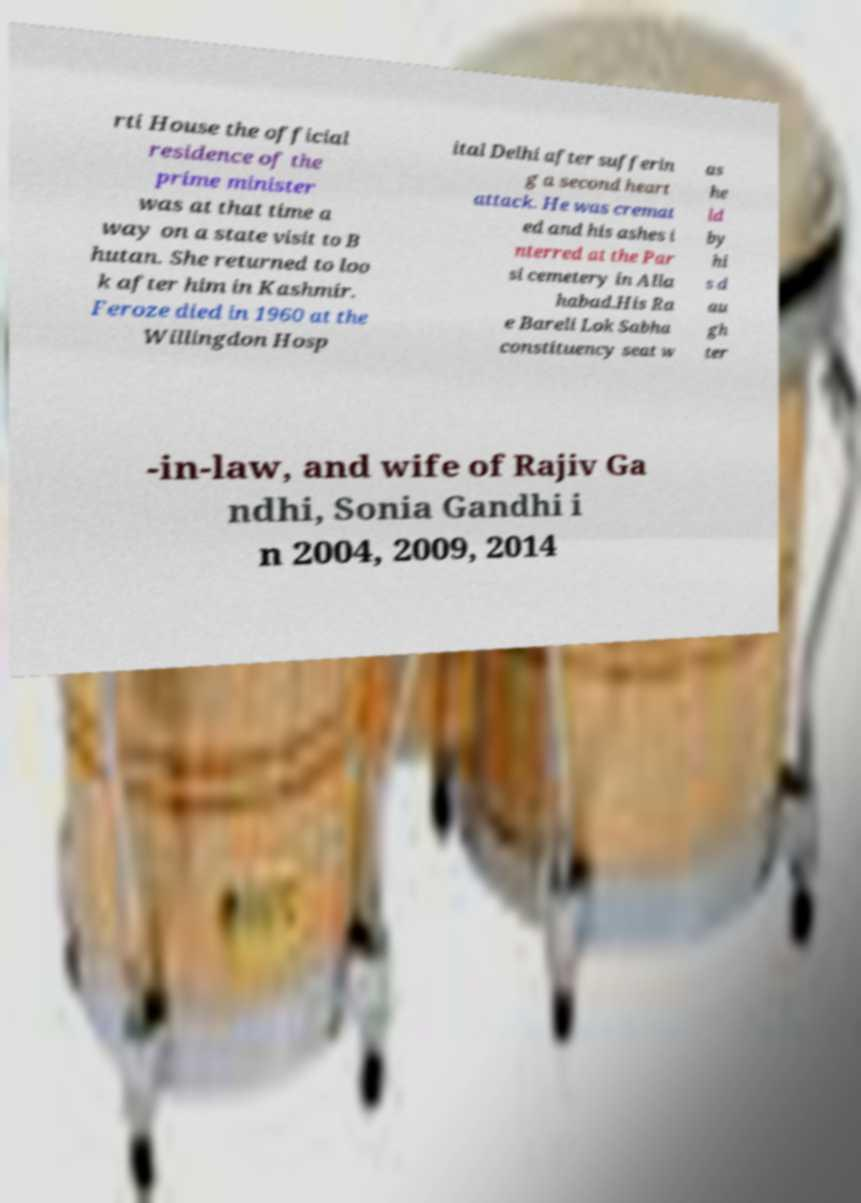Could you assist in decoding the text presented in this image and type it out clearly? rti House the official residence of the prime minister was at that time a way on a state visit to B hutan. She returned to loo k after him in Kashmir. Feroze died in 1960 at the Willingdon Hosp ital Delhi after sufferin g a second heart attack. He was cremat ed and his ashes i nterred at the Par si cemetery in Alla habad.His Ra e Bareli Lok Sabha constituency seat w as he ld by hi s d au gh ter -in-law, and wife of Rajiv Ga ndhi, Sonia Gandhi i n 2004, 2009, 2014 